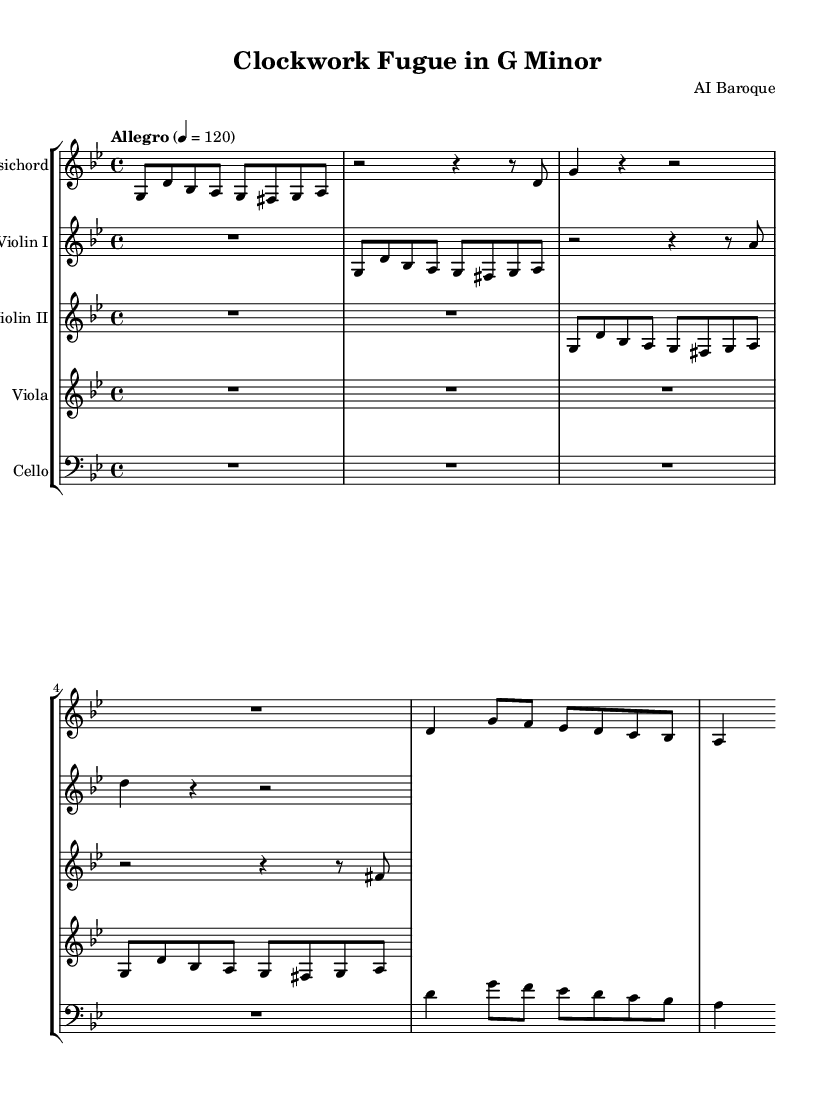What is the key signature of this music? The key signature is G minor, which has two flats (B flat and E flat). You can identify the key signature on the left side of the staff, where the flats are notated.
Answer: G minor What is the time signature of this piece? The time signature is 4/4, indicated at the beginning of the staff. The "4" on the top represents four beats in a measure, and the "4" on the bottom signifies that a quarter note receives one beat.
Answer: 4/4 What is the tempo marking of this piece? The tempo marking is "Allegro," noted at the beginning with a metronome speed of 120 beats per minute. This indicates that the music should be played lively and at a fast pace.
Answer: Allegro Which instruments are featured in this composition? The instruments included in this composition are the Harpsichord, Violin I, Violin II, Viola, and Cello. You can identify them from the labels at the beginning of each staff in the score.
Answer: Harpsichord, Violin I, Violin II, Viola, Cello How many measures of rest are there for the cello part? The cello has four measures of rest at the beginning, indicated by the absence of notes in its part, which is shown as R1 for the rests. This means the cello does not play until the counter-subject starts.
Answer: 4 What is the main theme's rhythmic pattern in the harpsichord part? In the harpsichord part, the main theme consists of a mix of eighth notes and longer values like half and quarter notes. The theme begins with a sequence of eighth notes followed by a quarter note, establishing a lively rhythmic feel characteristic of Baroque music.
Answer: Eighth notes and quarter notes What musical form does this piece seem to exemplify? This piece exemplifies the fugue form, as indicated by the interplay of the main theme and counter-subject, which is a characteristic structure of Baroque instrumental music that often features interwoven melodies.
Answer: Fugue 